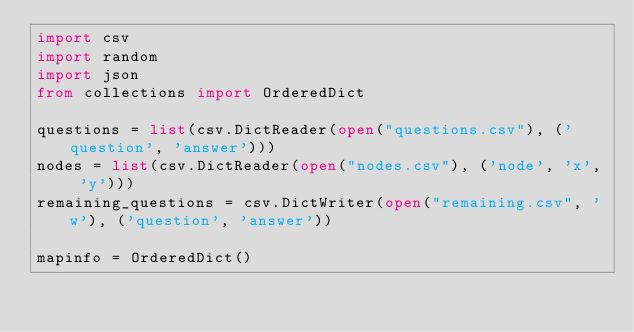Convert code to text. <code><loc_0><loc_0><loc_500><loc_500><_Python_>import csv
import random
import json
from collections import OrderedDict

questions = list(csv.DictReader(open("questions.csv"), ('question', 'answer')))
nodes = list(csv.DictReader(open("nodes.csv"), ('node', 'x', 'y')))
remaining_questions = csv.DictWriter(open("remaining.csv", 'w'), ('question', 'answer'))

mapinfo = OrderedDict()</code> 